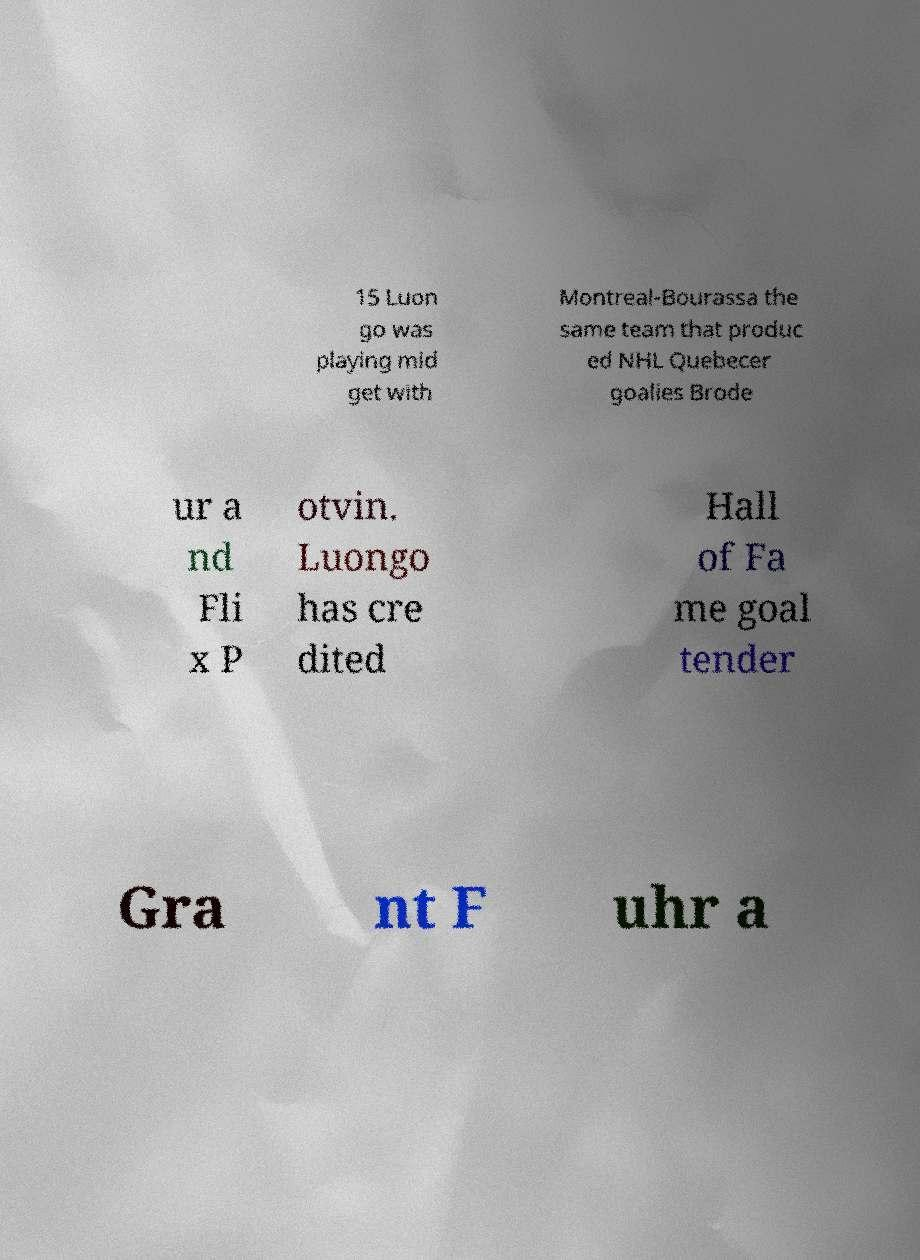Can you read and provide the text displayed in the image?This photo seems to have some interesting text. Can you extract and type it out for me? 15 Luon go was playing mid get with Montreal-Bourassa the same team that produc ed NHL Quebecer goalies Brode ur a nd Fli x P otvin. Luongo has cre dited Hall of Fa me goal tender Gra nt F uhr a 